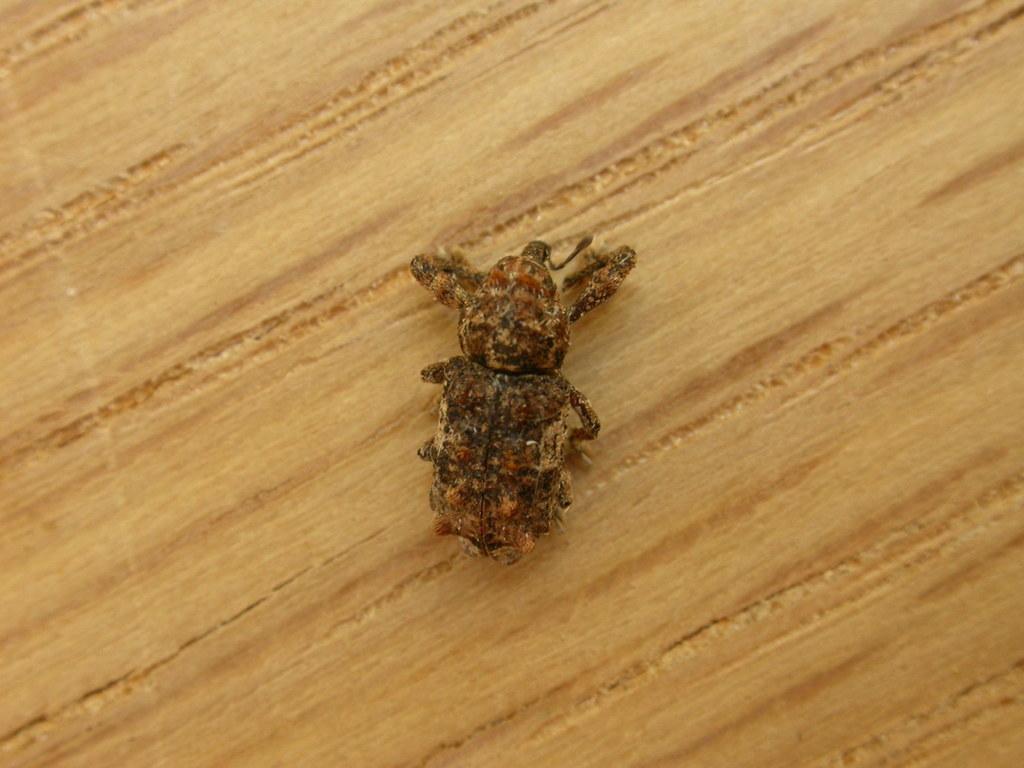Please provide a concise description of this image. In this image we can see an insect on a wooden surface. 